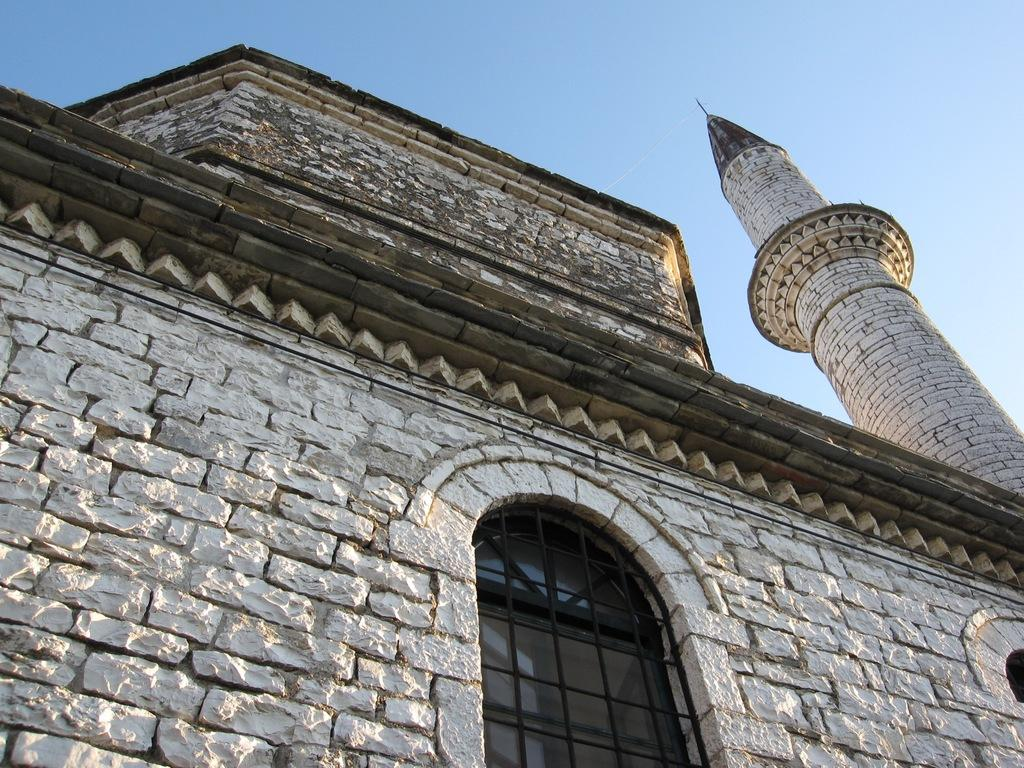What type of structure is visible in the image? There is a building in the image. What are the walls made of in the building? The building has walls. What type of window is present on the building? There is a glass window on the building. What cooking appliance can be seen in the image? There is a grill in the image. What additional architectural feature is present in the image? There is a tower in the image. What is visible in the background of the image? The sky is visible in the background of the image. What type of force is being exerted on the building in the image? There is no indication of any force being exerted on the building in the image. What type of hot food is being prepared on the grill in the image? There is no food visible on the grill in the image. 